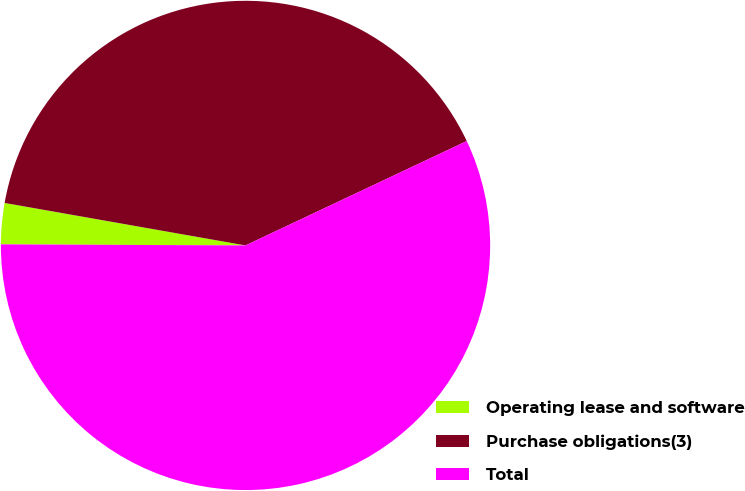Convert chart. <chart><loc_0><loc_0><loc_500><loc_500><pie_chart><fcel>Operating lease and software<fcel>Purchase obligations(3)<fcel>Total<nl><fcel>2.71%<fcel>40.21%<fcel>57.09%<nl></chart> 